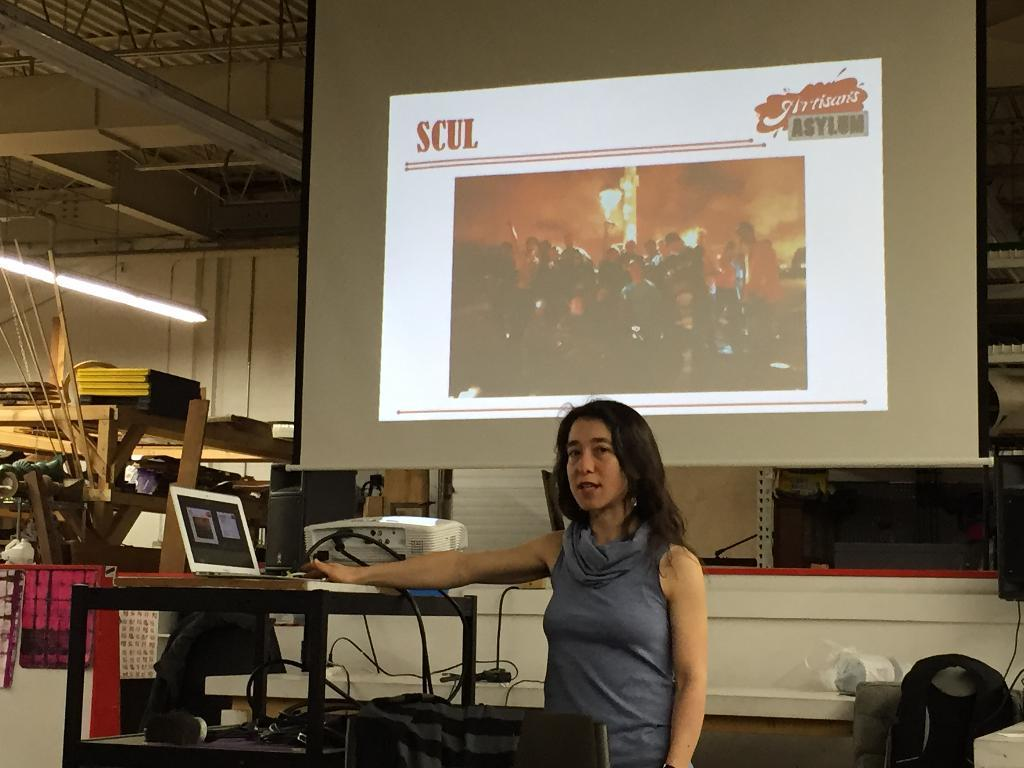<image>
Render a clear and concise summary of the photo. A woman is presenting in front of a large screen that has SCUL displayed on the right. 